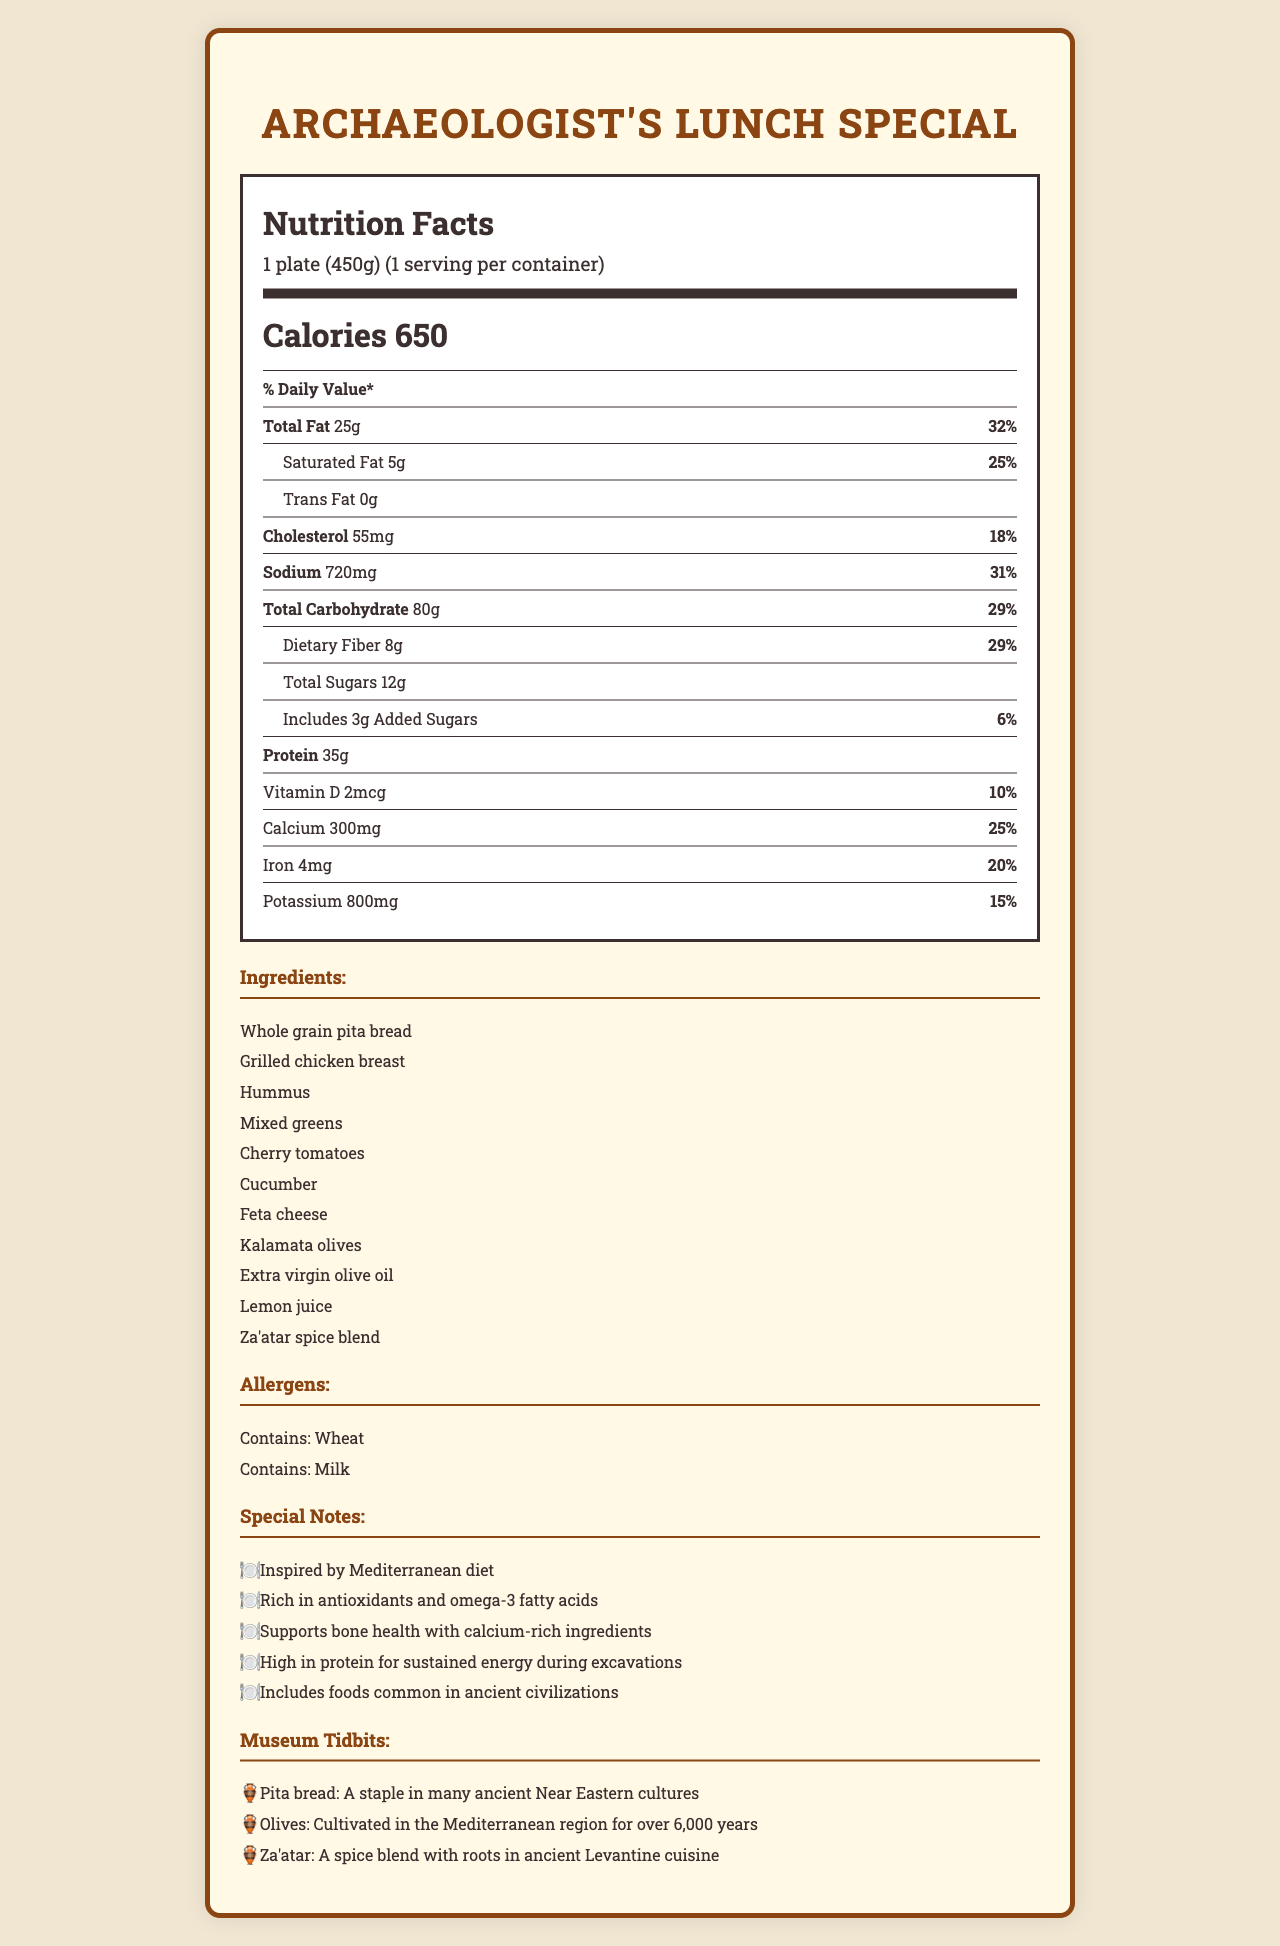what is the serving size? The serving size is mentioned at the top of the Nutrition Facts label as "1 plate (450g)".
Answer: 1 plate (450g) how many calories are in one serving? The number of calories per serving is listed as 650 in the calorie info section.
Answer: 650 what is the total fat content in one plate of Archaeologist's Lunch Special? The total fat content is shown under the nutrient row as "Total Fat 25g".
Answer: 25g what are the total carbohydrates in this meal? The total carbohydrate amount is listed in the nutrient rows as "Total Carbohydrate 80g".
Answer: 80g which vitamins and minerals are highlighted in the document? The vitamins and minerals are mentioned individually in the nutrient rows: Vitamin D, Calcium, Iron, and Potassium.
Answer: Vitamin D, Calcium, Iron, Potassium what percentage of the daily value of sodium does one serving contain? A. 18% B. 25% C. 31% D. 32% The sodium content is listed with a daily value percentage of 31%.
Answer: C. 31% which ingredient is NOT included in the Archaeologist's Lunch Special? A. Grilled Chicken B. Feta Cheese C. Tofu D. Hummus Tofu is not listed among the ingredients, but Grilled Chicken, Feta Cheese, and Hummus are.
Answer: C. Tofu does the meal contain trans fat? The nutrition facts list Trans Fat as "0g", indicating there is no trans fat in the meal.
Answer: No is the meal inspired by the Mediterranean diet? Under the special notes section, it states "Inspired by Mediterranean diet".
Answer: Yes summarize the content of the document. The document provides comprehensive nutritional information, ingredients, allergens, and special notes emphasizing the health benefits and historical significance of components in the meal.
Answer: The document details the Nutrition Facts of the "Archaeologist's Lunch Special," including the serving size, calorie count, and detailed nutrient information. It lists the ingredients, potential allergens, and special nutritional benefits. Additionally, it includes historical tidbits related to the ingredients. what are some health benefits mentioned in the special notes? The special notes section lists several health benefits, including being rich in antioxidants and omega-3 fatty acids, supporting bone health with calcium-rich ingredients, and providing high protein for sustained energy.
Answer: Rich in antioxidants and omega-3 fatty acids, supports bone health with calcium-rich ingredients, high in protein for sustained energy during excavations what percentage of daily fiber does the meal provide? The dietary fiber percent daily value is listed as 29% in the nutrient rows.
Answer: 29% what is the relationship between pita bread and ancient cultures? According to the museum tidbits section, pita bread was a staple in many ancient Near Eastern cultures.
Answer: Pita bread was a staple in many ancient Near Eastern cultures how much-added sugar is in the meal? The added sugars amount is listed as "Includes 3g Added Sugars".
Answer: 3g why do you think the special is called "Archaeologist's Lunch"? The document does not provide a specific reason for the name "Archaeologist's Lunch".
Answer: Not enough information 